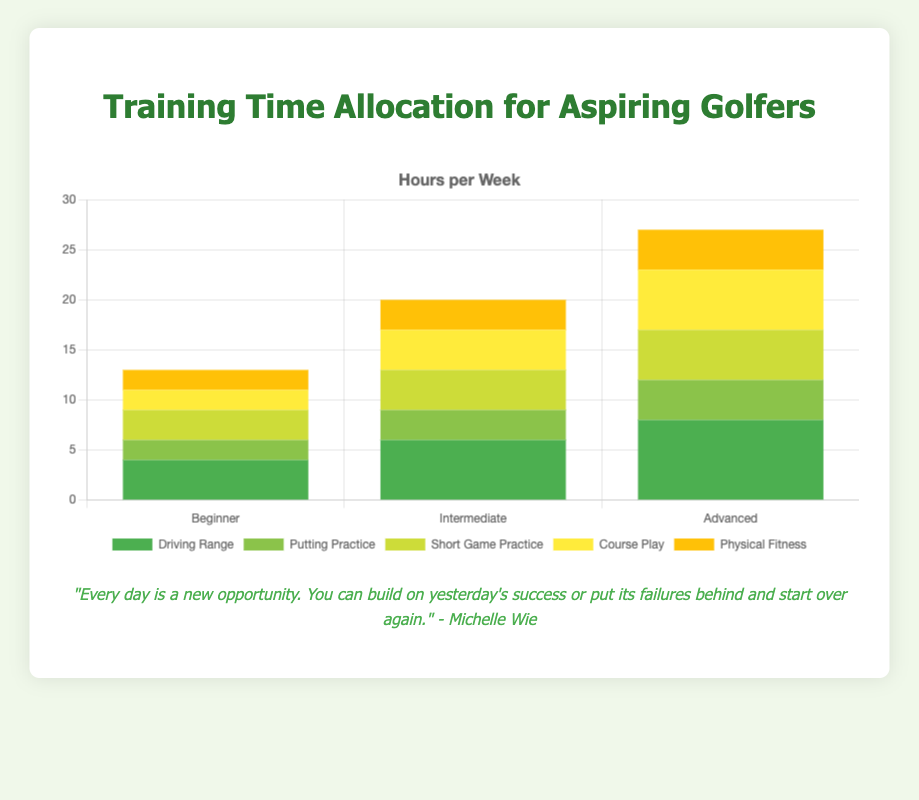What category has the largest increase in training hours from Beginner to Advanced? The driving range category has hours increasing from 4 for beginners to 8 for advanced, which is an increase of 4 hours. No other category shows such a large increase.
Answer: Driving Range How many total hours per week do Advanced golfers train? Summing the hours for all categories for Advanced golfers gives (8 + 4 + 5 + 6 + 4) = 27 hours.
Answer: 27 What is the difference in Course Play hours per week between Beginner and Advanced golfers? Beginner golfers spend 2 hours on Course Play, while Advanced golfers spend 6 hours. The difference is 6 - 2 = 4 hours.
Answer: 4 Which skill level spends the least amount of time on Putting Practice? Beginners spend 2 hours per week on Putting Practice, which is less than both Intermediate (3 hours) and Advanced (4 hours).
Answer: Beginner If Intermediate golfers redistributed their training time evenly among all categories, how many hours would be allocated per category? Total hours for Intermediate golfers = (6 + 3 + 4 + 4 + 3) = 20 hours. Dividing evenly among 5 categories gives 20/5 = 4 hours per category.
Answer: 4 How many hours do Beginners spend on Short Game Practice and Physical Fitness combined? Beginners spend 3 hours on Short Game Practice and 2 hours on Physical Fitness. The combined total is 3 + 2 = 5 hours.
Answer: 5 What is the difference in total training hours between Intermediate and Advanced golfers? Intermediate golfers have a total of (6 + 3 + 4 + 4 + 3) = 20 hours and Advanced golfers have (8 + 4 + 5 + 6 + 4) = 27 hours. The difference is 27 - 20 = 7 hours.
Answer: 7 Which category shows the same number of training hours for Beginners and Intermediate golfers? Both Beginners and Intermediate golfers spend 2 and 3 hours on Physical Fitness respectively.
Answer: None How many additional hours per week does an Advanced golfer spend on Course Play compared to a Beginner? Advanced golfers spend 6 hours on Course Play, while Beginner golfers spend 2 hours. The additional time is 6 - 2 = 4 hours.
Answer: 4 If you combine the time spent on Driving Range and Putting Practice, which skill level spends the most hours? Advanced golfers spend (8 + 4) = 12 hours on Driving Range and Putting Practice, which is more than Beginners (6 hours) and Intermediates (9 hours).
Answer: Advanced 